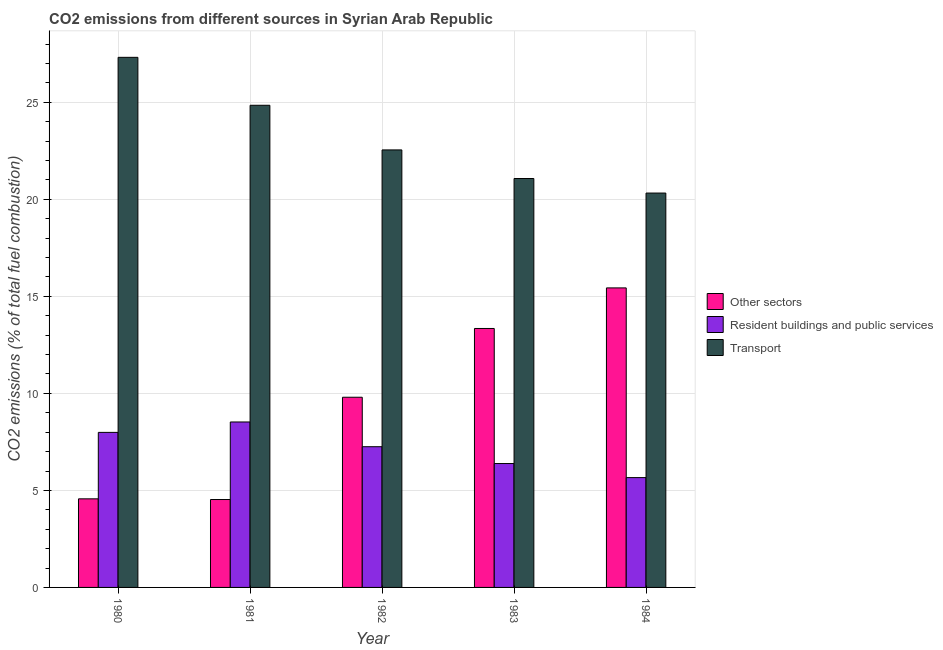How many different coloured bars are there?
Offer a very short reply. 3. How many groups of bars are there?
Provide a short and direct response. 5. How many bars are there on the 5th tick from the left?
Make the answer very short. 3. How many bars are there on the 3rd tick from the right?
Keep it short and to the point. 3. What is the percentage of co2 emissions from resident buildings and public services in 1981?
Offer a terse response. 8.53. Across all years, what is the maximum percentage of co2 emissions from other sectors?
Your answer should be compact. 15.44. Across all years, what is the minimum percentage of co2 emissions from other sectors?
Give a very brief answer. 4.53. In which year was the percentage of co2 emissions from transport minimum?
Your answer should be compact. 1984. What is the total percentage of co2 emissions from resident buildings and public services in the graph?
Keep it short and to the point. 35.82. What is the difference between the percentage of co2 emissions from resident buildings and public services in 1980 and that in 1982?
Keep it short and to the point. 0.74. What is the difference between the percentage of co2 emissions from other sectors in 1983 and the percentage of co2 emissions from transport in 1981?
Your answer should be compact. 8.82. What is the average percentage of co2 emissions from other sectors per year?
Provide a short and direct response. 9.54. What is the ratio of the percentage of co2 emissions from transport in 1980 to that in 1981?
Offer a terse response. 1.1. What is the difference between the highest and the second highest percentage of co2 emissions from other sectors?
Your response must be concise. 2.09. What is the difference between the highest and the lowest percentage of co2 emissions from resident buildings and public services?
Provide a succinct answer. 2.87. In how many years, is the percentage of co2 emissions from transport greater than the average percentage of co2 emissions from transport taken over all years?
Your response must be concise. 2. What does the 3rd bar from the left in 1983 represents?
Ensure brevity in your answer.  Transport. What does the 2nd bar from the right in 1983 represents?
Your response must be concise. Resident buildings and public services. Is it the case that in every year, the sum of the percentage of co2 emissions from other sectors and percentage of co2 emissions from resident buildings and public services is greater than the percentage of co2 emissions from transport?
Provide a short and direct response. No. How many years are there in the graph?
Ensure brevity in your answer.  5. Are the values on the major ticks of Y-axis written in scientific E-notation?
Your response must be concise. No. Does the graph contain any zero values?
Give a very brief answer. No. Does the graph contain grids?
Give a very brief answer. Yes. Where does the legend appear in the graph?
Your response must be concise. Center right. What is the title of the graph?
Your answer should be very brief. CO2 emissions from different sources in Syrian Arab Republic. What is the label or title of the Y-axis?
Offer a terse response. CO2 emissions (% of total fuel combustion). What is the CO2 emissions (% of total fuel combustion) of Other sectors in 1980?
Your answer should be very brief. 4.57. What is the CO2 emissions (% of total fuel combustion) of Resident buildings and public services in 1980?
Make the answer very short. 7.99. What is the CO2 emissions (% of total fuel combustion) of Transport in 1980?
Make the answer very short. 27.32. What is the CO2 emissions (% of total fuel combustion) of Other sectors in 1981?
Give a very brief answer. 4.53. What is the CO2 emissions (% of total fuel combustion) in Resident buildings and public services in 1981?
Make the answer very short. 8.53. What is the CO2 emissions (% of total fuel combustion) in Transport in 1981?
Offer a terse response. 24.85. What is the CO2 emissions (% of total fuel combustion) in Other sectors in 1982?
Offer a very short reply. 9.8. What is the CO2 emissions (% of total fuel combustion) in Resident buildings and public services in 1982?
Provide a succinct answer. 7.25. What is the CO2 emissions (% of total fuel combustion) in Transport in 1982?
Ensure brevity in your answer.  22.55. What is the CO2 emissions (% of total fuel combustion) of Other sectors in 1983?
Your answer should be compact. 13.35. What is the CO2 emissions (% of total fuel combustion) of Resident buildings and public services in 1983?
Offer a terse response. 6.39. What is the CO2 emissions (% of total fuel combustion) in Transport in 1983?
Provide a succinct answer. 21.08. What is the CO2 emissions (% of total fuel combustion) of Other sectors in 1984?
Keep it short and to the point. 15.44. What is the CO2 emissions (% of total fuel combustion) in Resident buildings and public services in 1984?
Your answer should be compact. 5.66. What is the CO2 emissions (% of total fuel combustion) of Transport in 1984?
Your response must be concise. 20.33. Across all years, what is the maximum CO2 emissions (% of total fuel combustion) in Other sectors?
Offer a terse response. 15.44. Across all years, what is the maximum CO2 emissions (% of total fuel combustion) of Resident buildings and public services?
Give a very brief answer. 8.53. Across all years, what is the maximum CO2 emissions (% of total fuel combustion) of Transport?
Your answer should be very brief. 27.32. Across all years, what is the minimum CO2 emissions (% of total fuel combustion) of Other sectors?
Provide a succinct answer. 4.53. Across all years, what is the minimum CO2 emissions (% of total fuel combustion) in Resident buildings and public services?
Keep it short and to the point. 5.66. Across all years, what is the minimum CO2 emissions (% of total fuel combustion) in Transport?
Provide a short and direct response. 20.33. What is the total CO2 emissions (% of total fuel combustion) of Other sectors in the graph?
Make the answer very short. 47.68. What is the total CO2 emissions (% of total fuel combustion) of Resident buildings and public services in the graph?
Give a very brief answer. 35.82. What is the total CO2 emissions (% of total fuel combustion) of Transport in the graph?
Keep it short and to the point. 116.12. What is the difference between the CO2 emissions (% of total fuel combustion) of Other sectors in 1980 and that in 1981?
Your answer should be very brief. 0.04. What is the difference between the CO2 emissions (% of total fuel combustion) of Resident buildings and public services in 1980 and that in 1981?
Your answer should be very brief. -0.54. What is the difference between the CO2 emissions (% of total fuel combustion) in Transport in 1980 and that in 1981?
Your answer should be compact. 2.47. What is the difference between the CO2 emissions (% of total fuel combustion) of Other sectors in 1980 and that in 1982?
Your answer should be very brief. -5.24. What is the difference between the CO2 emissions (% of total fuel combustion) in Resident buildings and public services in 1980 and that in 1982?
Your answer should be compact. 0.74. What is the difference between the CO2 emissions (% of total fuel combustion) in Transport in 1980 and that in 1982?
Ensure brevity in your answer.  4.77. What is the difference between the CO2 emissions (% of total fuel combustion) of Other sectors in 1980 and that in 1983?
Offer a very short reply. -8.78. What is the difference between the CO2 emissions (% of total fuel combustion) in Resident buildings and public services in 1980 and that in 1983?
Offer a very short reply. 1.61. What is the difference between the CO2 emissions (% of total fuel combustion) in Transport in 1980 and that in 1983?
Give a very brief answer. 6.25. What is the difference between the CO2 emissions (% of total fuel combustion) of Other sectors in 1980 and that in 1984?
Your answer should be compact. -10.87. What is the difference between the CO2 emissions (% of total fuel combustion) of Resident buildings and public services in 1980 and that in 1984?
Keep it short and to the point. 2.33. What is the difference between the CO2 emissions (% of total fuel combustion) in Transport in 1980 and that in 1984?
Your answer should be compact. 7. What is the difference between the CO2 emissions (% of total fuel combustion) of Other sectors in 1981 and that in 1982?
Make the answer very short. -5.27. What is the difference between the CO2 emissions (% of total fuel combustion) in Resident buildings and public services in 1981 and that in 1982?
Give a very brief answer. 1.28. What is the difference between the CO2 emissions (% of total fuel combustion) of Transport in 1981 and that in 1982?
Offer a very short reply. 2.3. What is the difference between the CO2 emissions (% of total fuel combustion) of Other sectors in 1981 and that in 1983?
Your answer should be very brief. -8.82. What is the difference between the CO2 emissions (% of total fuel combustion) in Resident buildings and public services in 1981 and that in 1983?
Your answer should be very brief. 2.14. What is the difference between the CO2 emissions (% of total fuel combustion) in Transport in 1981 and that in 1983?
Your answer should be very brief. 3.77. What is the difference between the CO2 emissions (% of total fuel combustion) in Other sectors in 1981 and that in 1984?
Ensure brevity in your answer.  -10.91. What is the difference between the CO2 emissions (% of total fuel combustion) of Resident buildings and public services in 1981 and that in 1984?
Keep it short and to the point. 2.87. What is the difference between the CO2 emissions (% of total fuel combustion) of Transport in 1981 and that in 1984?
Your answer should be very brief. 4.52. What is the difference between the CO2 emissions (% of total fuel combustion) in Other sectors in 1982 and that in 1983?
Give a very brief answer. -3.54. What is the difference between the CO2 emissions (% of total fuel combustion) in Resident buildings and public services in 1982 and that in 1983?
Provide a succinct answer. 0.87. What is the difference between the CO2 emissions (% of total fuel combustion) in Transport in 1982 and that in 1983?
Your answer should be very brief. 1.47. What is the difference between the CO2 emissions (% of total fuel combustion) of Other sectors in 1982 and that in 1984?
Provide a short and direct response. -5.64. What is the difference between the CO2 emissions (% of total fuel combustion) of Resident buildings and public services in 1982 and that in 1984?
Provide a succinct answer. 1.59. What is the difference between the CO2 emissions (% of total fuel combustion) of Transport in 1982 and that in 1984?
Provide a succinct answer. 2.22. What is the difference between the CO2 emissions (% of total fuel combustion) of Other sectors in 1983 and that in 1984?
Your answer should be compact. -2.09. What is the difference between the CO2 emissions (% of total fuel combustion) of Resident buildings and public services in 1983 and that in 1984?
Give a very brief answer. 0.72. What is the difference between the CO2 emissions (% of total fuel combustion) of Transport in 1983 and that in 1984?
Offer a terse response. 0.75. What is the difference between the CO2 emissions (% of total fuel combustion) of Other sectors in 1980 and the CO2 emissions (% of total fuel combustion) of Resident buildings and public services in 1981?
Provide a short and direct response. -3.96. What is the difference between the CO2 emissions (% of total fuel combustion) in Other sectors in 1980 and the CO2 emissions (% of total fuel combustion) in Transport in 1981?
Your answer should be compact. -20.28. What is the difference between the CO2 emissions (% of total fuel combustion) of Resident buildings and public services in 1980 and the CO2 emissions (% of total fuel combustion) of Transport in 1981?
Ensure brevity in your answer.  -16.86. What is the difference between the CO2 emissions (% of total fuel combustion) of Other sectors in 1980 and the CO2 emissions (% of total fuel combustion) of Resident buildings and public services in 1982?
Your answer should be very brief. -2.69. What is the difference between the CO2 emissions (% of total fuel combustion) of Other sectors in 1980 and the CO2 emissions (% of total fuel combustion) of Transport in 1982?
Give a very brief answer. -17.98. What is the difference between the CO2 emissions (% of total fuel combustion) in Resident buildings and public services in 1980 and the CO2 emissions (% of total fuel combustion) in Transport in 1982?
Make the answer very short. -14.56. What is the difference between the CO2 emissions (% of total fuel combustion) of Other sectors in 1980 and the CO2 emissions (% of total fuel combustion) of Resident buildings and public services in 1983?
Offer a terse response. -1.82. What is the difference between the CO2 emissions (% of total fuel combustion) in Other sectors in 1980 and the CO2 emissions (% of total fuel combustion) in Transport in 1983?
Keep it short and to the point. -16.51. What is the difference between the CO2 emissions (% of total fuel combustion) of Resident buildings and public services in 1980 and the CO2 emissions (% of total fuel combustion) of Transport in 1983?
Ensure brevity in your answer.  -13.08. What is the difference between the CO2 emissions (% of total fuel combustion) of Other sectors in 1980 and the CO2 emissions (% of total fuel combustion) of Resident buildings and public services in 1984?
Provide a succinct answer. -1.09. What is the difference between the CO2 emissions (% of total fuel combustion) of Other sectors in 1980 and the CO2 emissions (% of total fuel combustion) of Transport in 1984?
Provide a short and direct response. -15.76. What is the difference between the CO2 emissions (% of total fuel combustion) of Resident buildings and public services in 1980 and the CO2 emissions (% of total fuel combustion) of Transport in 1984?
Your response must be concise. -12.34. What is the difference between the CO2 emissions (% of total fuel combustion) of Other sectors in 1981 and the CO2 emissions (% of total fuel combustion) of Resident buildings and public services in 1982?
Ensure brevity in your answer.  -2.72. What is the difference between the CO2 emissions (% of total fuel combustion) of Other sectors in 1981 and the CO2 emissions (% of total fuel combustion) of Transport in 1982?
Provide a short and direct response. -18.02. What is the difference between the CO2 emissions (% of total fuel combustion) in Resident buildings and public services in 1981 and the CO2 emissions (% of total fuel combustion) in Transport in 1982?
Your response must be concise. -14.02. What is the difference between the CO2 emissions (% of total fuel combustion) in Other sectors in 1981 and the CO2 emissions (% of total fuel combustion) in Resident buildings and public services in 1983?
Your response must be concise. -1.85. What is the difference between the CO2 emissions (% of total fuel combustion) in Other sectors in 1981 and the CO2 emissions (% of total fuel combustion) in Transport in 1983?
Offer a very short reply. -16.55. What is the difference between the CO2 emissions (% of total fuel combustion) in Resident buildings and public services in 1981 and the CO2 emissions (% of total fuel combustion) in Transport in 1983?
Ensure brevity in your answer.  -12.55. What is the difference between the CO2 emissions (% of total fuel combustion) in Other sectors in 1981 and the CO2 emissions (% of total fuel combustion) in Resident buildings and public services in 1984?
Your answer should be very brief. -1.13. What is the difference between the CO2 emissions (% of total fuel combustion) of Other sectors in 1981 and the CO2 emissions (% of total fuel combustion) of Transport in 1984?
Ensure brevity in your answer.  -15.8. What is the difference between the CO2 emissions (% of total fuel combustion) of Resident buildings and public services in 1981 and the CO2 emissions (% of total fuel combustion) of Transport in 1984?
Offer a very short reply. -11.8. What is the difference between the CO2 emissions (% of total fuel combustion) in Other sectors in 1982 and the CO2 emissions (% of total fuel combustion) in Resident buildings and public services in 1983?
Your answer should be compact. 3.42. What is the difference between the CO2 emissions (% of total fuel combustion) of Other sectors in 1982 and the CO2 emissions (% of total fuel combustion) of Transport in 1983?
Offer a terse response. -11.27. What is the difference between the CO2 emissions (% of total fuel combustion) of Resident buildings and public services in 1982 and the CO2 emissions (% of total fuel combustion) of Transport in 1983?
Offer a terse response. -13.82. What is the difference between the CO2 emissions (% of total fuel combustion) of Other sectors in 1982 and the CO2 emissions (% of total fuel combustion) of Resident buildings and public services in 1984?
Ensure brevity in your answer.  4.14. What is the difference between the CO2 emissions (% of total fuel combustion) of Other sectors in 1982 and the CO2 emissions (% of total fuel combustion) of Transport in 1984?
Offer a very short reply. -10.52. What is the difference between the CO2 emissions (% of total fuel combustion) in Resident buildings and public services in 1982 and the CO2 emissions (% of total fuel combustion) in Transport in 1984?
Give a very brief answer. -13.07. What is the difference between the CO2 emissions (% of total fuel combustion) of Other sectors in 1983 and the CO2 emissions (% of total fuel combustion) of Resident buildings and public services in 1984?
Keep it short and to the point. 7.69. What is the difference between the CO2 emissions (% of total fuel combustion) in Other sectors in 1983 and the CO2 emissions (% of total fuel combustion) in Transport in 1984?
Make the answer very short. -6.98. What is the difference between the CO2 emissions (% of total fuel combustion) of Resident buildings and public services in 1983 and the CO2 emissions (% of total fuel combustion) of Transport in 1984?
Keep it short and to the point. -13.94. What is the average CO2 emissions (% of total fuel combustion) of Other sectors per year?
Provide a succinct answer. 9.54. What is the average CO2 emissions (% of total fuel combustion) in Resident buildings and public services per year?
Provide a succinct answer. 7.16. What is the average CO2 emissions (% of total fuel combustion) in Transport per year?
Your response must be concise. 23.22. In the year 1980, what is the difference between the CO2 emissions (% of total fuel combustion) of Other sectors and CO2 emissions (% of total fuel combustion) of Resident buildings and public services?
Keep it short and to the point. -3.42. In the year 1980, what is the difference between the CO2 emissions (% of total fuel combustion) of Other sectors and CO2 emissions (% of total fuel combustion) of Transport?
Ensure brevity in your answer.  -22.75. In the year 1980, what is the difference between the CO2 emissions (% of total fuel combustion) in Resident buildings and public services and CO2 emissions (% of total fuel combustion) in Transport?
Offer a terse response. -19.33. In the year 1981, what is the difference between the CO2 emissions (% of total fuel combustion) in Other sectors and CO2 emissions (% of total fuel combustion) in Resident buildings and public services?
Offer a terse response. -4. In the year 1981, what is the difference between the CO2 emissions (% of total fuel combustion) of Other sectors and CO2 emissions (% of total fuel combustion) of Transport?
Your response must be concise. -20.32. In the year 1981, what is the difference between the CO2 emissions (% of total fuel combustion) of Resident buildings and public services and CO2 emissions (% of total fuel combustion) of Transport?
Make the answer very short. -16.32. In the year 1982, what is the difference between the CO2 emissions (% of total fuel combustion) in Other sectors and CO2 emissions (% of total fuel combustion) in Resident buildings and public services?
Your answer should be very brief. 2.55. In the year 1982, what is the difference between the CO2 emissions (% of total fuel combustion) of Other sectors and CO2 emissions (% of total fuel combustion) of Transport?
Keep it short and to the point. -12.75. In the year 1982, what is the difference between the CO2 emissions (% of total fuel combustion) of Resident buildings and public services and CO2 emissions (% of total fuel combustion) of Transport?
Offer a terse response. -15.3. In the year 1983, what is the difference between the CO2 emissions (% of total fuel combustion) of Other sectors and CO2 emissions (% of total fuel combustion) of Resident buildings and public services?
Your answer should be compact. 6.96. In the year 1983, what is the difference between the CO2 emissions (% of total fuel combustion) of Other sectors and CO2 emissions (% of total fuel combustion) of Transport?
Offer a terse response. -7.73. In the year 1983, what is the difference between the CO2 emissions (% of total fuel combustion) of Resident buildings and public services and CO2 emissions (% of total fuel combustion) of Transport?
Provide a short and direct response. -14.69. In the year 1984, what is the difference between the CO2 emissions (% of total fuel combustion) of Other sectors and CO2 emissions (% of total fuel combustion) of Resident buildings and public services?
Offer a very short reply. 9.78. In the year 1984, what is the difference between the CO2 emissions (% of total fuel combustion) of Other sectors and CO2 emissions (% of total fuel combustion) of Transport?
Your response must be concise. -4.89. In the year 1984, what is the difference between the CO2 emissions (% of total fuel combustion) in Resident buildings and public services and CO2 emissions (% of total fuel combustion) in Transport?
Ensure brevity in your answer.  -14.67. What is the ratio of the CO2 emissions (% of total fuel combustion) of Other sectors in 1980 to that in 1981?
Make the answer very short. 1.01. What is the ratio of the CO2 emissions (% of total fuel combustion) of Resident buildings and public services in 1980 to that in 1981?
Make the answer very short. 0.94. What is the ratio of the CO2 emissions (% of total fuel combustion) of Transport in 1980 to that in 1981?
Keep it short and to the point. 1.1. What is the ratio of the CO2 emissions (% of total fuel combustion) in Other sectors in 1980 to that in 1982?
Your response must be concise. 0.47. What is the ratio of the CO2 emissions (% of total fuel combustion) in Resident buildings and public services in 1980 to that in 1982?
Make the answer very short. 1.1. What is the ratio of the CO2 emissions (% of total fuel combustion) in Transport in 1980 to that in 1982?
Ensure brevity in your answer.  1.21. What is the ratio of the CO2 emissions (% of total fuel combustion) in Other sectors in 1980 to that in 1983?
Give a very brief answer. 0.34. What is the ratio of the CO2 emissions (% of total fuel combustion) in Resident buildings and public services in 1980 to that in 1983?
Keep it short and to the point. 1.25. What is the ratio of the CO2 emissions (% of total fuel combustion) of Transport in 1980 to that in 1983?
Offer a terse response. 1.3. What is the ratio of the CO2 emissions (% of total fuel combustion) in Other sectors in 1980 to that in 1984?
Offer a terse response. 0.3. What is the ratio of the CO2 emissions (% of total fuel combustion) of Resident buildings and public services in 1980 to that in 1984?
Your answer should be compact. 1.41. What is the ratio of the CO2 emissions (% of total fuel combustion) in Transport in 1980 to that in 1984?
Offer a very short reply. 1.34. What is the ratio of the CO2 emissions (% of total fuel combustion) of Other sectors in 1981 to that in 1982?
Ensure brevity in your answer.  0.46. What is the ratio of the CO2 emissions (% of total fuel combustion) in Resident buildings and public services in 1981 to that in 1982?
Your answer should be very brief. 1.18. What is the ratio of the CO2 emissions (% of total fuel combustion) of Transport in 1981 to that in 1982?
Offer a very short reply. 1.1. What is the ratio of the CO2 emissions (% of total fuel combustion) in Other sectors in 1981 to that in 1983?
Your response must be concise. 0.34. What is the ratio of the CO2 emissions (% of total fuel combustion) in Resident buildings and public services in 1981 to that in 1983?
Offer a very short reply. 1.34. What is the ratio of the CO2 emissions (% of total fuel combustion) of Transport in 1981 to that in 1983?
Offer a terse response. 1.18. What is the ratio of the CO2 emissions (% of total fuel combustion) in Other sectors in 1981 to that in 1984?
Offer a terse response. 0.29. What is the ratio of the CO2 emissions (% of total fuel combustion) of Resident buildings and public services in 1981 to that in 1984?
Offer a terse response. 1.51. What is the ratio of the CO2 emissions (% of total fuel combustion) in Transport in 1981 to that in 1984?
Your answer should be compact. 1.22. What is the ratio of the CO2 emissions (% of total fuel combustion) of Other sectors in 1982 to that in 1983?
Offer a terse response. 0.73. What is the ratio of the CO2 emissions (% of total fuel combustion) of Resident buildings and public services in 1982 to that in 1983?
Give a very brief answer. 1.14. What is the ratio of the CO2 emissions (% of total fuel combustion) in Transport in 1982 to that in 1983?
Provide a short and direct response. 1.07. What is the ratio of the CO2 emissions (% of total fuel combustion) in Other sectors in 1982 to that in 1984?
Your answer should be compact. 0.63. What is the ratio of the CO2 emissions (% of total fuel combustion) of Resident buildings and public services in 1982 to that in 1984?
Provide a succinct answer. 1.28. What is the ratio of the CO2 emissions (% of total fuel combustion) of Transport in 1982 to that in 1984?
Offer a very short reply. 1.11. What is the ratio of the CO2 emissions (% of total fuel combustion) of Other sectors in 1983 to that in 1984?
Keep it short and to the point. 0.86. What is the ratio of the CO2 emissions (% of total fuel combustion) in Resident buildings and public services in 1983 to that in 1984?
Ensure brevity in your answer.  1.13. What is the ratio of the CO2 emissions (% of total fuel combustion) in Transport in 1983 to that in 1984?
Provide a succinct answer. 1.04. What is the difference between the highest and the second highest CO2 emissions (% of total fuel combustion) of Other sectors?
Your answer should be very brief. 2.09. What is the difference between the highest and the second highest CO2 emissions (% of total fuel combustion) in Resident buildings and public services?
Provide a short and direct response. 0.54. What is the difference between the highest and the second highest CO2 emissions (% of total fuel combustion) of Transport?
Your answer should be very brief. 2.47. What is the difference between the highest and the lowest CO2 emissions (% of total fuel combustion) of Other sectors?
Ensure brevity in your answer.  10.91. What is the difference between the highest and the lowest CO2 emissions (% of total fuel combustion) of Resident buildings and public services?
Keep it short and to the point. 2.87. What is the difference between the highest and the lowest CO2 emissions (% of total fuel combustion) in Transport?
Offer a terse response. 7. 